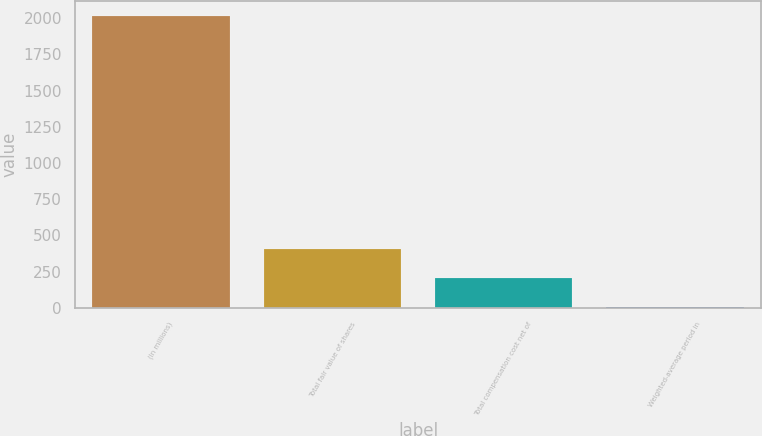Convert chart. <chart><loc_0><loc_0><loc_500><loc_500><bar_chart><fcel>(In millions)<fcel>Total fair value of shares<fcel>Total compensation cost net of<fcel>Weighted-average period in<nl><fcel>2017<fcel>405<fcel>203.5<fcel>2<nl></chart> 